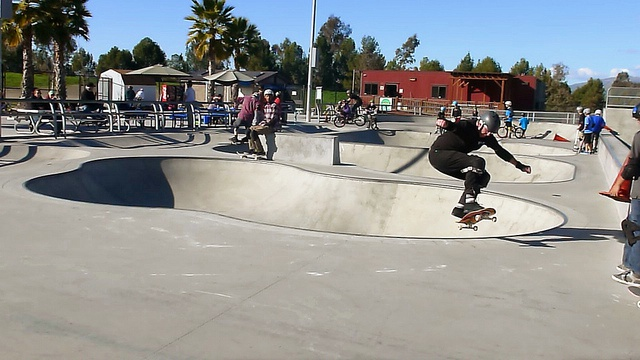Describe the objects in this image and their specific colors. I can see people in gray, black, lightgray, and darkgray tones, people in gray, black, darkgray, and lightgray tones, people in gray, black, lightgray, and darkgray tones, bench in gray, black, white, and darkgray tones, and bench in gray, black, darkgray, and white tones in this image. 